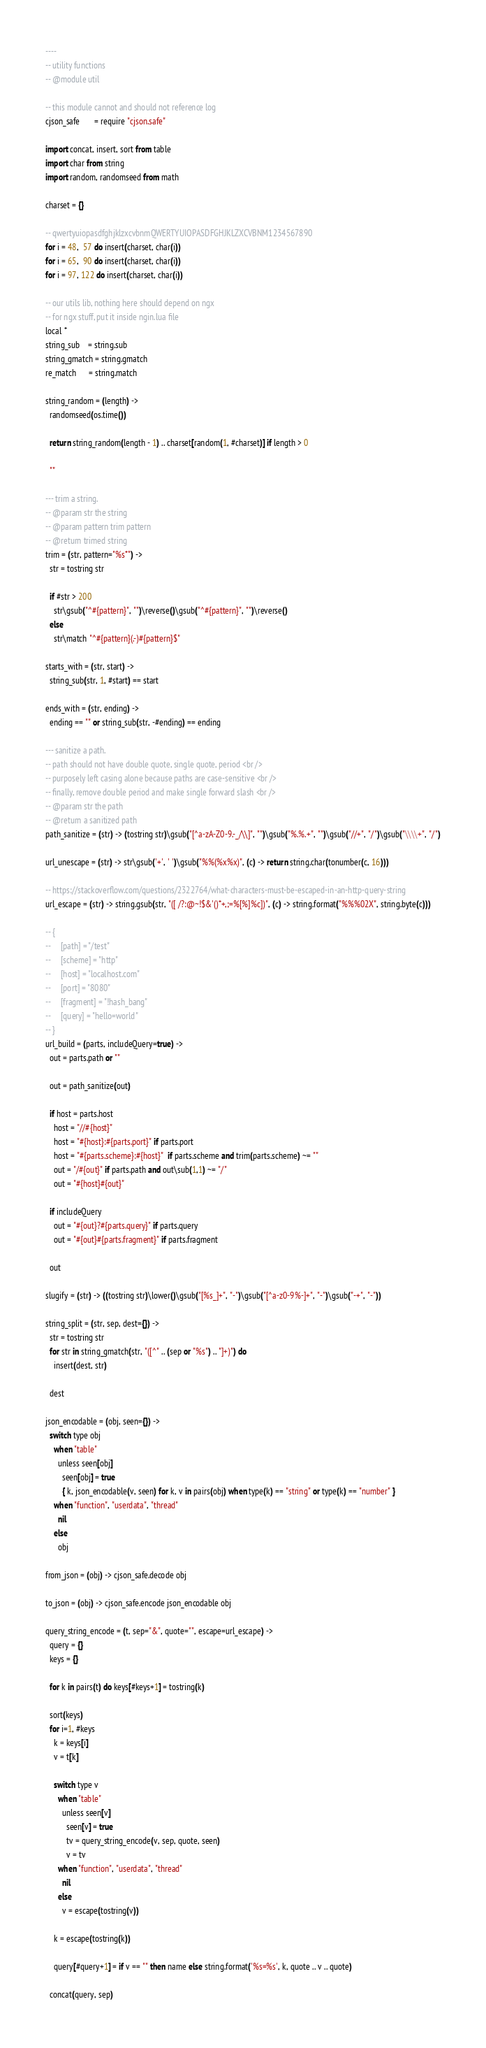<code> <loc_0><loc_0><loc_500><loc_500><_MoonScript_>----
-- utility functions
-- @module util

-- this module cannot and should not reference log
cjson_safe       = require "cjson.safe"

import concat, insert, sort from table
import char from string
import random, randomseed from math

charset = {}

-- qwertyuiopasdfghjklzxcvbnmQWERTYUIOPASDFGHJKLZXCVBNM1234567890
for i = 48,  57 do insert(charset, char(i))
for i = 65,  90 do insert(charset, char(i))
for i = 97, 122 do insert(charset, char(i))

-- our utils lib, nothing here should depend on ngx
-- for ngx stuff, put it inside ngin.lua file
local *
string_sub    = string.sub
string_gmatch = string.gmatch
re_match      = string.match

string_random = (length) ->
  randomseed(os.time())

  return string_random(length - 1) .. charset[random(1, #charset)] if length > 0

  ""

--- trim a string.
-- @param str the string
-- @param pattern trim pattern
-- @return trimed string
trim = (str, pattern="%s*") ->
  str = tostring str

  if #str > 200
    str\gsub("^#{pattern}", "")\reverse()\gsub("^#{pattern}", "")\reverse()
  else
    str\match "^#{pattern}(.-)#{pattern}$"

starts_with = (str, start) ->
  string_sub(str, 1, #start) == start

ends_with = (str, ending) ->
  ending == "" or string_sub(str, -#ending) == ending

--- sanitize a path.
-- path should not have double quote, single quote, period <br />
-- purposely left casing alone because paths are case-sensitive <br />
-- finally, remove double period and make single forward slash <br />
-- @param str the path
-- @return a sanitized path
path_sanitize = (str) -> (tostring str)\gsub("[^a-zA-Z0-9.-_/\\]", "")\gsub("%.%.+", "")\gsub("//+", "/")\gsub("\\\\+", "/")

url_unescape = (str) -> str\gsub('+', ' ')\gsub("%%(%x%x)", (c) -> return string.char(tonumber(c, 16)))

-- https://stackoverflow.com/questions/2322764/what-characters-must-be-escaped-in-an-http-query-string
url_escape = (str) -> string.gsub(str, "([ /?:@~!$&'()*+,;=%[%]%c])", (c) -> string.format("%%%02X", string.byte(c)))

-- {
--     [path] = "/test"
--     [scheme] = "http"
--     [host] = "localhost.com"
--     [port] = "8080"
--     [fragment] = "!hash_bang"
--     [query] = "hello=world"
-- }
url_build = (parts, includeQuery=true) ->
  out = parts.path or ""

  out = path_sanitize(out)

  if host = parts.host
    host = "//#{host}"
    host = "#{host}:#{parts.port}" if parts.port
    host = "#{parts.scheme}:#{host}"  if parts.scheme and trim(parts.scheme) ~= ""
    out = "/#{out}" if parts.path and out\sub(1,1) ~= "/"
    out = "#{host}#{out}"

  if includeQuery
    out = "#{out}?#{parts.query}" if parts.query
    out = "#{out}#{parts.fragment}" if parts.fragment

  out

slugify = (str) -> ((tostring str)\lower()\gsub("[%s_]+", "-")\gsub("[^a-z0-9%-]+", "-")\gsub("-+", "-"))

string_split = (str, sep, dest={}) ->
  str = tostring str
  for str in string_gmatch(str, "([^" .. (sep or "%s") .. "]+)") do
    insert(dest, str)

  dest

json_encodable = (obj, seen={}) ->
  switch type obj
    when "table"
      unless seen[obj]
        seen[obj] = true
        { k, json_encodable(v, seen) for k, v in pairs(obj) when type(k) == "string" or type(k) == "number" }
    when "function", "userdata", "thread"
      nil
    else
      obj

from_json = (obj) -> cjson_safe.decode obj

to_json = (obj) -> cjson_safe.encode json_encodable obj

query_string_encode = (t, sep="&", quote="", escape=url_escape) ->
  query = {}
  keys = {}

  for k in pairs(t) do keys[#keys+1] = tostring(k)

  sort(keys)
  for i=1, #keys
    k = keys[i]
    v = t[k]

    switch type v
      when "table"
        unless seen[v]
          seen[v] = true
          tv = query_string_encode(v, sep, quote, seen)
          v = tv
      when "function", "userdata", "thread"
        nil
      else
        v = escape(tostring(v))

    k = escape(tostring(k))

    query[#query+1] = if v == "" then name else string.format('%s=%s', k, quote .. v .. quote)

  concat(query, sep)
</code> 